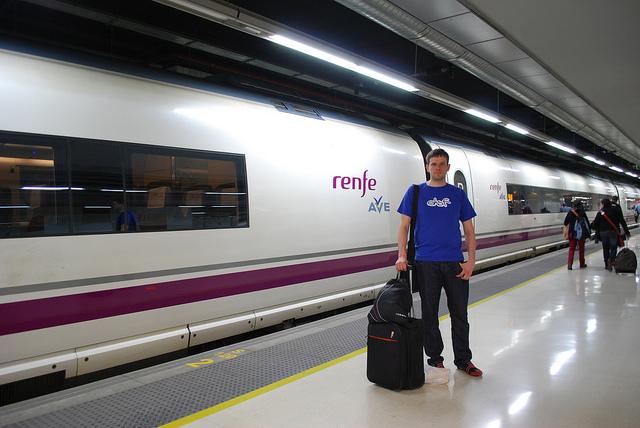What does the red letter say?
Keep it brief. Renfe. Is this guy planning to travel by train?
Short answer required. Yes. What is the person toting along?
Short answer required. Luggage. 